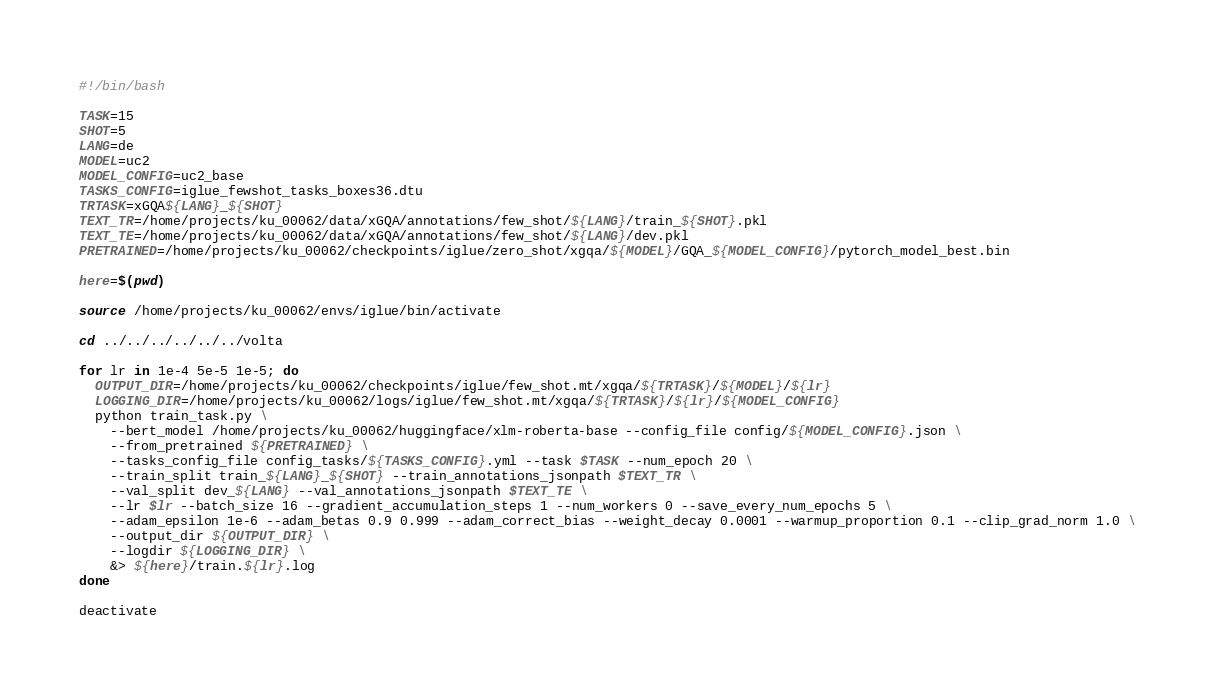Convert code to text. <code><loc_0><loc_0><loc_500><loc_500><_Bash_>#!/bin/bash

TASK=15
SHOT=5
LANG=de
MODEL=uc2
MODEL_CONFIG=uc2_base
TASKS_CONFIG=iglue_fewshot_tasks_boxes36.dtu
TRTASK=xGQA${LANG}_${SHOT}
TEXT_TR=/home/projects/ku_00062/data/xGQA/annotations/few_shot/${LANG}/train_${SHOT}.pkl
TEXT_TE=/home/projects/ku_00062/data/xGQA/annotations/few_shot/${LANG}/dev.pkl
PRETRAINED=/home/projects/ku_00062/checkpoints/iglue/zero_shot/xgqa/${MODEL}/GQA_${MODEL_CONFIG}/pytorch_model_best.bin

here=$(pwd)

source /home/projects/ku_00062/envs/iglue/bin/activate

cd ../../../../../../volta

for lr in 1e-4 5e-5 1e-5; do
  OUTPUT_DIR=/home/projects/ku_00062/checkpoints/iglue/few_shot.mt/xgqa/${TRTASK}/${MODEL}/${lr}
  LOGGING_DIR=/home/projects/ku_00062/logs/iglue/few_shot.mt/xgqa/${TRTASK}/${lr}/${MODEL_CONFIG}
  python train_task.py \
    --bert_model /home/projects/ku_00062/huggingface/xlm-roberta-base --config_file config/${MODEL_CONFIG}.json \
    --from_pretrained ${PRETRAINED} \
    --tasks_config_file config_tasks/${TASKS_CONFIG}.yml --task $TASK --num_epoch 20 \
    --train_split train_${LANG}_${SHOT} --train_annotations_jsonpath $TEXT_TR \
    --val_split dev_${LANG} --val_annotations_jsonpath $TEXT_TE \
    --lr $lr --batch_size 16 --gradient_accumulation_steps 1 --num_workers 0 --save_every_num_epochs 5 \
    --adam_epsilon 1e-6 --adam_betas 0.9 0.999 --adam_correct_bias --weight_decay 0.0001 --warmup_proportion 0.1 --clip_grad_norm 1.0 \
    --output_dir ${OUTPUT_DIR} \
    --logdir ${LOGGING_DIR} \
    &> ${here}/train.${lr}.log
done

deactivate
</code> 